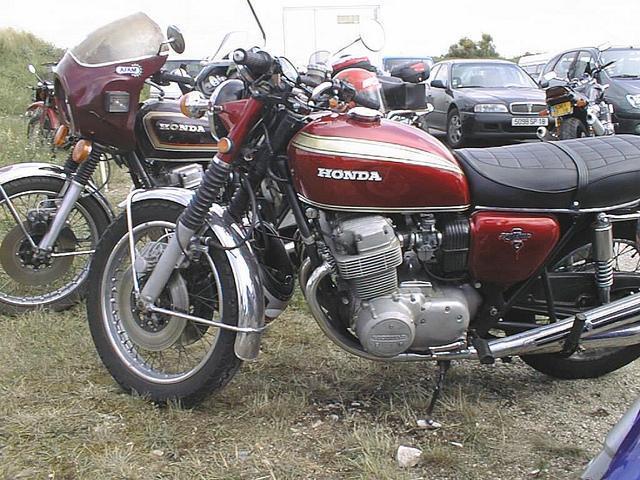How many motorcycles are there?
Give a very brief answer. 3. How many cars can be seen?
Give a very brief answer. 2. 